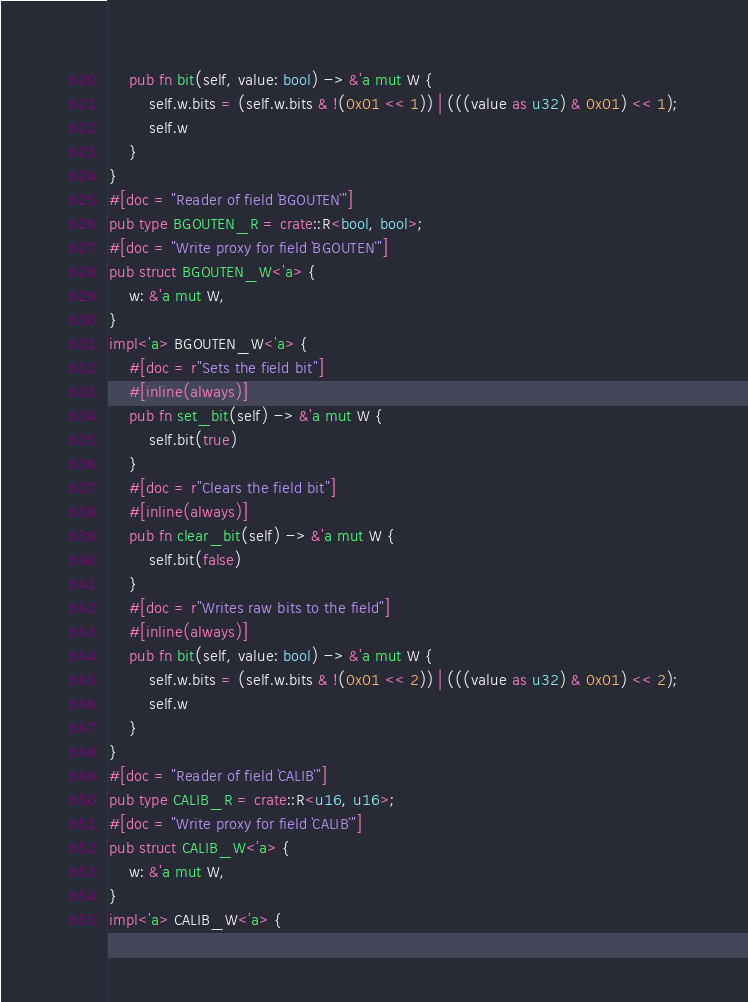<code> <loc_0><loc_0><loc_500><loc_500><_Rust_>    pub fn bit(self, value: bool) -> &'a mut W {
        self.w.bits = (self.w.bits & !(0x01 << 1)) | (((value as u32) & 0x01) << 1);
        self.w
    }
}
#[doc = "Reader of field `BGOUTEN`"]
pub type BGOUTEN_R = crate::R<bool, bool>;
#[doc = "Write proxy for field `BGOUTEN`"]
pub struct BGOUTEN_W<'a> {
    w: &'a mut W,
}
impl<'a> BGOUTEN_W<'a> {
    #[doc = r"Sets the field bit"]
    #[inline(always)]
    pub fn set_bit(self) -> &'a mut W {
        self.bit(true)
    }
    #[doc = r"Clears the field bit"]
    #[inline(always)]
    pub fn clear_bit(self) -> &'a mut W {
        self.bit(false)
    }
    #[doc = r"Writes raw bits to the field"]
    #[inline(always)]
    pub fn bit(self, value: bool) -> &'a mut W {
        self.w.bits = (self.w.bits & !(0x01 << 2)) | (((value as u32) & 0x01) << 2);
        self.w
    }
}
#[doc = "Reader of field `CALIB`"]
pub type CALIB_R = crate::R<u16, u16>;
#[doc = "Write proxy for field `CALIB`"]
pub struct CALIB_W<'a> {
    w: &'a mut W,
}
impl<'a> CALIB_W<'a> {</code> 